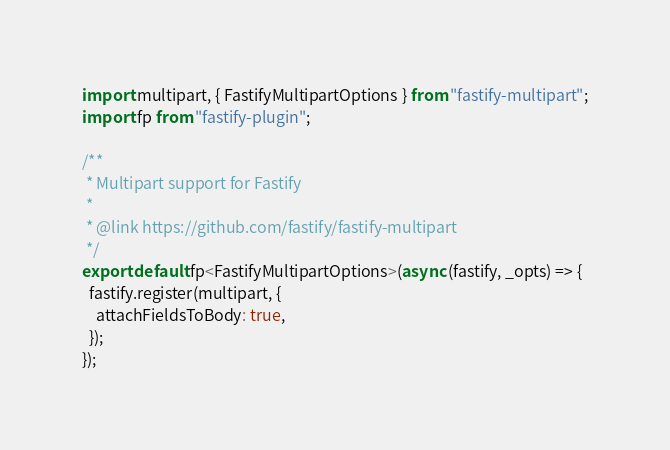Convert code to text. <code><loc_0><loc_0><loc_500><loc_500><_TypeScript_>import multipart, { FastifyMultipartOptions } from "fastify-multipart";
import fp from "fastify-plugin";

/**
 * Multipart support for Fastify
 *
 * @link https://github.com/fastify/fastify-multipart
 */
export default fp<FastifyMultipartOptions>(async (fastify, _opts) => {
  fastify.register(multipart, {
    attachFieldsToBody: true,
  });
});
</code> 